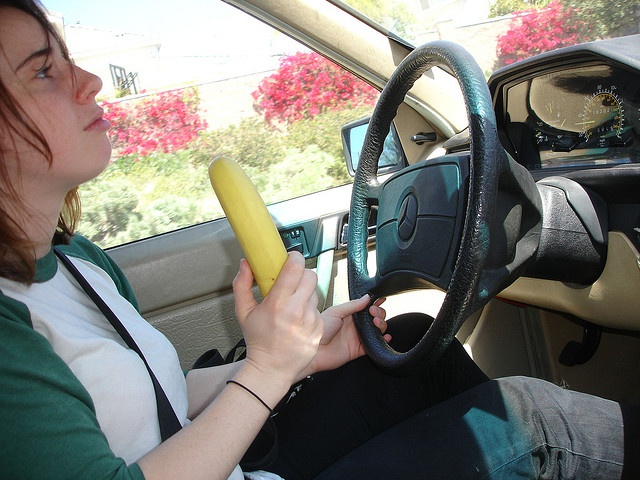Describe the objects in this image and their specific colors. I can see people in gray, black, darkgray, and teal tones, potted plant in black, lightpink, gray, darkgray, and white tones, and banana in black, khaki, and olive tones in this image. 